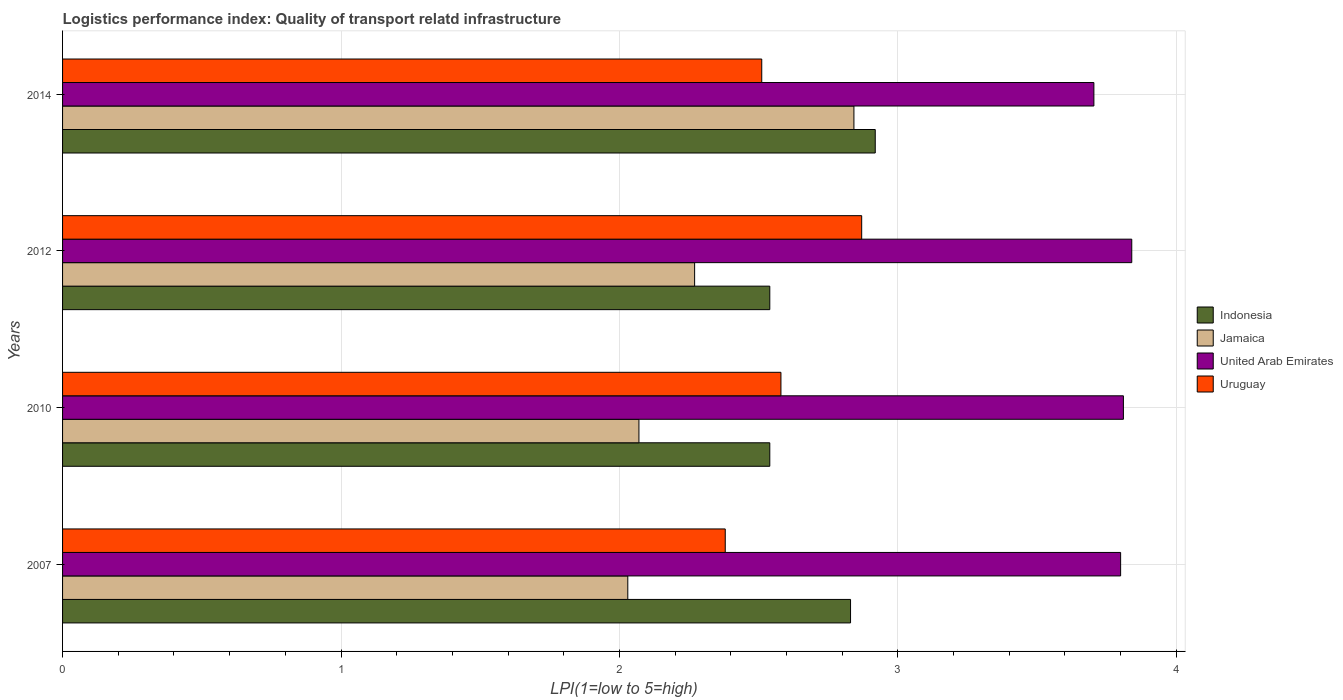How many different coloured bars are there?
Ensure brevity in your answer.  4. Are the number of bars per tick equal to the number of legend labels?
Your answer should be compact. Yes. Are the number of bars on each tick of the Y-axis equal?
Give a very brief answer. Yes. In how many cases, is the number of bars for a given year not equal to the number of legend labels?
Your answer should be very brief. 0. What is the logistics performance index in United Arab Emirates in 2010?
Offer a very short reply. 3.81. Across all years, what is the maximum logistics performance index in United Arab Emirates?
Your answer should be compact. 3.84. Across all years, what is the minimum logistics performance index in Jamaica?
Keep it short and to the point. 2.03. In which year was the logistics performance index in Uruguay maximum?
Your answer should be very brief. 2012. What is the total logistics performance index in Uruguay in the graph?
Give a very brief answer. 10.34. What is the difference between the logistics performance index in United Arab Emirates in 2010 and that in 2014?
Your answer should be very brief. 0.11. What is the difference between the logistics performance index in Indonesia in 2014 and the logistics performance index in Uruguay in 2012?
Give a very brief answer. 0.05. What is the average logistics performance index in Jamaica per year?
Keep it short and to the point. 2.3. In the year 2007, what is the difference between the logistics performance index in Uruguay and logistics performance index in Jamaica?
Offer a terse response. 0.35. What is the ratio of the logistics performance index in Jamaica in 2007 to that in 2010?
Your answer should be compact. 0.98. Is the logistics performance index in Indonesia in 2012 less than that in 2014?
Make the answer very short. Yes. Is the difference between the logistics performance index in Uruguay in 2007 and 2012 greater than the difference between the logistics performance index in Jamaica in 2007 and 2012?
Your answer should be compact. No. What is the difference between the highest and the second highest logistics performance index in Jamaica?
Make the answer very short. 0.57. What is the difference between the highest and the lowest logistics performance index in United Arab Emirates?
Ensure brevity in your answer.  0.14. In how many years, is the logistics performance index in Indonesia greater than the average logistics performance index in Indonesia taken over all years?
Ensure brevity in your answer.  2. Is the sum of the logistics performance index in Uruguay in 2007 and 2014 greater than the maximum logistics performance index in Indonesia across all years?
Offer a terse response. Yes. Is it the case that in every year, the sum of the logistics performance index in Indonesia and logistics performance index in United Arab Emirates is greater than the sum of logistics performance index in Uruguay and logistics performance index in Jamaica?
Provide a short and direct response. Yes. What does the 1st bar from the top in 2010 represents?
Give a very brief answer. Uruguay. What does the 3rd bar from the bottom in 2014 represents?
Ensure brevity in your answer.  United Arab Emirates. How many years are there in the graph?
Offer a very short reply. 4. Are the values on the major ticks of X-axis written in scientific E-notation?
Your answer should be very brief. No. Does the graph contain any zero values?
Your response must be concise. No. Does the graph contain grids?
Offer a terse response. Yes. What is the title of the graph?
Your answer should be very brief. Logistics performance index: Quality of transport relatd infrastructure. Does "Algeria" appear as one of the legend labels in the graph?
Your answer should be compact. No. What is the label or title of the X-axis?
Your answer should be compact. LPI(1=low to 5=high). What is the label or title of the Y-axis?
Your answer should be compact. Years. What is the LPI(1=low to 5=high) in Indonesia in 2007?
Keep it short and to the point. 2.83. What is the LPI(1=low to 5=high) in Jamaica in 2007?
Ensure brevity in your answer.  2.03. What is the LPI(1=low to 5=high) in Uruguay in 2007?
Make the answer very short. 2.38. What is the LPI(1=low to 5=high) of Indonesia in 2010?
Your response must be concise. 2.54. What is the LPI(1=low to 5=high) of Jamaica in 2010?
Offer a very short reply. 2.07. What is the LPI(1=low to 5=high) in United Arab Emirates in 2010?
Offer a very short reply. 3.81. What is the LPI(1=low to 5=high) of Uruguay in 2010?
Keep it short and to the point. 2.58. What is the LPI(1=low to 5=high) in Indonesia in 2012?
Offer a very short reply. 2.54. What is the LPI(1=low to 5=high) of Jamaica in 2012?
Your response must be concise. 2.27. What is the LPI(1=low to 5=high) of United Arab Emirates in 2012?
Keep it short and to the point. 3.84. What is the LPI(1=low to 5=high) of Uruguay in 2012?
Offer a terse response. 2.87. What is the LPI(1=low to 5=high) of Indonesia in 2014?
Make the answer very short. 2.92. What is the LPI(1=low to 5=high) in Jamaica in 2014?
Provide a succinct answer. 2.84. What is the LPI(1=low to 5=high) of United Arab Emirates in 2014?
Your answer should be very brief. 3.7. What is the LPI(1=low to 5=high) in Uruguay in 2014?
Make the answer very short. 2.51. Across all years, what is the maximum LPI(1=low to 5=high) in Indonesia?
Your answer should be compact. 2.92. Across all years, what is the maximum LPI(1=low to 5=high) in Jamaica?
Your answer should be compact. 2.84. Across all years, what is the maximum LPI(1=low to 5=high) of United Arab Emirates?
Your response must be concise. 3.84. Across all years, what is the maximum LPI(1=low to 5=high) in Uruguay?
Offer a very short reply. 2.87. Across all years, what is the minimum LPI(1=low to 5=high) in Indonesia?
Provide a succinct answer. 2.54. Across all years, what is the minimum LPI(1=low to 5=high) of Jamaica?
Make the answer very short. 2.03. Across all years, what is the minimum LPI(1=low to 5=high) in United Arab Emirates?
Ensure brevity in your answer.  3.7. Across all years, what is the minimum LPI(1=low to 5=high) of Uruguay?
Your response must be concise. 2.38. What is the total LPI(1=low to 5=high) in Indonesia in the graph?
Offer a terse response. 10.83. What is the total LPI(1=low to 5=high) of Jamaica in the graph?
Ensure brevity in your answer.  9.21. What is the total LPI(1=low to 5=high) of United Arab Emirates in the graph?
Make the answer very short. 15.15. What is the total LPI(1=low to 5=high) in Uruguay in the graph?
Offer a terse response. 10.34. What is the difference between the LPI(1=low to 5=high) of Indonesia in 2007 and that in 2010?
Offer a terse response. 0.29. What is the difference between the LPI(1=low to 5=high) in Jamaica in 2007 and that in 2010?
Your answer should be compact. -0.04. What is the difference between the LPI(1=low to 5=high) in United Arab Emirates in 2007 and that in 2010?
Offer a very short reply. -0.01. What is the difference between the LPI(1=low to 5=high) of Uruguay in 2007 and that in 2010?
Make the answer very short. -0.2. What is the difference between the LPI(1=low to 5=high) in Indonesia in 2007 and that in 2012?
Your answer should be compact. 0.29. What is the difference between the LPI(1=low to 5=high) in Jamaica in 2007 and that in 2012?
Keep it short and to the point. -0.24. What is the difference between the LPI(1=low to 5=high) of United Arab Emirates in 2007 and that in 2012?
Your answer should be very brief. -0.04. What is the difference between the LPI(1=low to 5=high) of Uruguay in 2007 and that in 2012?
Your response must be concise. -0.49. What is the difference between the LPI(1=low to 5=high) of Indonesia in 2007 and that in 2014?
Offer a very short reply. -0.09. What is the difference between the LPI(1=low to 5=high) in Jamaica in 2007 and that in 2014?
Provide a succinct answer. -0.81. What is the difference between the LPI(1=low to 5=high) in United Arab Emirates in 2007 and that in 2014?
Your response must be concise. 0.1. What is the difference between the LPI(1=low to 5=high) of Uruguay in 2007 and that in 2014?
Make the answer very short. -0.13. What is the difference between the LPI(1=low to 5=high) of Jamaica in 2010 and that in 2012?
Provide a succinct answer. -0.2. What is the difference between the LPI(1=low to 5=high) in United Arab Emirates in 2010 and that in 2012?
Offer a very short reply. -0.03. What is the difference between the LPI(1=low to 5=high) of Uruguay in 2010 and that in 2012?
Your response must be concise. -0.29. What is the difference between the LPI(1=low to 5=high) of Indonesia in 2010 and that in 2014?
Provide a short and direct response. -0.38. What is the difference between the LPI(1=low to 5=high) of Jamaica in 2010 and that in 2014?
Offer a terse response. -0.77. What is the difference between the LPI(1=low to 5=high) of United Arab Emirates in 2010 and that in 2014?
Your response must be concise. 0.11. What is the difference between the LPI(1=low to 5=high) of Uruguay in 2010 and that in 2014?
Your answer should be very brief. 0.07. What is the difference between the LPI(1=low to 5=high) of Indonesia in 2012 and that in 2014?
Ensure brevity in your answer.  -0.38. What is the difference between the LPI(1=low to 5=high) of Jamaica in 2012 and that in 2014?
Provide a succinct answer. -0.57. What is the difference between the LPI(1=low to 5=high) in United Arab Emirates in 2012 and that in 2014?
Your answer should be compact. 0.14. What is the difference between the LPI(1=low to 5=high) in Uruguay in 2012 and that in 2014?
Ensure brevity in your answer.  0.36. What is the difference between the LPI(1=low to 5=high) of Indonesia in 2007 and the LPI(1=low to 5=high) of Jamaica in 2010?
Offer a terse response. 0.76. What is the difference between the LPI(1=low to 5=high) in Indonesia in 2007 and the LPI(1=low to 5=high) in United Arab Emirates in 2010?
Ensure brevity in your answer.  -0.98. What is the difference between the LPI(1=low to 5=high) of Jamaica in 2007 and the LPI(1=low to 5=high) of United Arab Emirates in 2010?
Give a very brief answer. -1.78. What is the difference between the LPI(1=low to 5=high) of Jamaica in 2007 and the LPI(1=low to 5=high) of Uruguay in 2010?
Provide a succinct answer. -0.55. What is the difference between the LPI(1=low to 5=high) in United Arab Emirates in 2007 and the LPI(1=low to 5=high) in Uruguay in 2010?
Your response must be concise. 1.22. What is the difference between the LPI(1=low to 5=high) of Indonesia in 2007 and the LPI(1=low to 5=high) of Jamaica in 2012?
Your response must be concise. 0.56. What is the difference between the LPI(1=low to 5=high) of Indonesia in 2007 and the LPI(1=low to 5=high) of United Arab Emirates in 2012?
Make the answer very short. -1.01. What is the difference between the LPI(1=low to 5=high) of Indonesia in 2007 and the LPI(1=low to 5=high) of Uruguay in 2012?
Provide a succinct answer. -0.04. What is the difference between the LPI(1=low to 5=high) of Jamaica in 2007 and the LPI(1=low to 5=high) of United Arab Emirates in 2012?
Provide a succinct answer. -1.81. What is the difference between the LPI(1=low to 5=high) of Jamaica in 2007 and the LPI(1=low to 5=high) of Uruguay in 2012?
Provide a succinct answer. -0.84. What is the difference between the LPI(1=low to 5=high) in Indonesia in 2007 and the LPI(1=low to 5=high) in Jamaica in 2014?
Give a very brief answer. -0.01. What is the difference between the LPI(1=low to 5=high) in Indonesia in 2007 and the LPI(1=low to 5=high) in United Arab Emirates in 2014?
Your response must be concise. -0.87. What is the difference between the LPI(1=low to 5=high) in Indonesia in 2007 and the LPI(1=low to 5=high) in Uruguay in 2014?
Offer a very short reply. 0.32. What is the difference between the LPI(1=low to 5=high) of Jamaica in 2007 and the LPI(1=low to 5=high) of United Arab Emirates in 2014?
Offer a very short reply. -1.67. What is the difference between the LPI(1=low to 5=high) in Jamaica in 2007 and the LPI(1=low to 5=high) in Uruguay in 2014?
Your answer should be compact. -0.48. What is the difference between the LPI(1=low to 5=high) in United Arab Emirates in 2007 and the LPI(1=low to 5=high) in Uruguay in 2014?
Ensure brevity in your answer.  1.29. What is the difference between the LPI(1=low to 5=high) in Indonesia in 2010 and the LPI(1=low to 5=high) in Jamaica in 2012?
Make the answer very short. 0.27. What is the difference between the LPI(1=low to 5=high) in Indonesia in 2010 and the LPI(1=low to 5=high) in Uruguay in 2012?
Keep it short and to the point. -0.33. What is the difference between the LPI(1=low to 5=high) in Jamaica in 2010 and the LPI(1=low to 5=high) in United Arab Emirates in 2012?
Ensure brevity in your answer.  -1.77. What is the difference between the LPI(1=low to 5=high) of Jamaica in 2010 and the LPI(1=low to 5=high) of Uruguay in 2012?
Offer a terse response. -0.8. What is the difference between the LPI(1=low to 5=high) of United Arab Emirates in 2010 and the LPI(1=low to 5=high) of Uruguay in 2012?
Provide a succinct answer. 0.94. What is the difference between the LPI(1=low to 5=high) in Indonesia in 2010 and the LPI(1=low to 5=high) in Jamaica in 2014?
Your response must be concise. -0.3. What is the difference between the LPI(1=low to 5=high) in Indonesia in 2010 and the LPI(1=low to 5=high) in United Arab Emirates in 2014?
Make the answer very short. -1.16. What is the difference between the LPI(1=low to 5=high) in Indonesia in 2010 and the LPI(1=low to 5=high) in Uruguay in 2014?
Give a very brief answer. 0.03. What is the difference between the LPI(1=low to 5=high) of Jamaica in 2010 and the LPI(1=low to 5=high) of United Arab Emirates in 2014?
Provide a short and direct response. -1.63. What is the difference between the LPI(1=low to 5=high) of Jamaica in 2010 and the LPI(1=low to 5=high) of Uruguay in 2014?
Make the answer very short. -0.44. What is the difference between the LPI(1=low to 5=high) in United Arab Emirates in 2010 and the LPI(1=low to 5=high) in Uruguay in 2014?
Offer a terse response. 1.3. What is the difference between the LPI(1=low to 5=high) of Indonesia in 2012 and the LPI(1=low to 5=high) of Jamaica in 2014?
Provide a short and direct response. -0.3. What is the difference between the LPI(1=low to 5=high) in Indonesia in 2012 and the LPI(1=low to 5=high) in United Arab Emirates in 2014?
Keep it short and to the point. -1.16. What is the difference between the LPI(1=low to 5=high) of Indonesia in 2012 and the LPI(1=low to 5=high) of Uruguay in 2014?
Your response must be concise. 0.03. What is the difference between the LPI(1=low to 5=high) in Jamaica in 2012 and the LPI(1=low to 5=high) in United Arab Emirates in 2014?
Make the answer very short. -1.43. What is the difference between the LPI(1=low to 5=high) of Jamaica in 2012 and the LPI(1=low to 5=high) of Uruguay in 2014?
Provide a succinct answer. -0.24. What is the difference between the LPI(1=low to 5=high) in United Arab Emirates in 2012 and the LPI(1=low to 5=high) in Uruguay in 2014?
Keep it short and to the point. 1.33. What is the average LPI(1=low to 5=high) in Indonesia per year?
Your answer should be very brief. 2.71. What is the average LPI(1=low to 5=high) of Jamaica per year?
Your answer should be very brief. 2.3. What is the average LPI(1=low to 5=high) of United Arab Emirates per year?
Offer a very short reply. 3.79. What is the average LPI(1=low to 5=high) in Uruguay per year?
Give a very brief answer. 2.59. In the year 2007, what is the difference between the LPI(1=low to 5=high) in Indonesia and LPI(1=low to 5=high) in United Arab Emirates?
Ensure brevity in your answer.  -0.97. In the year 2007, what is the difference between the LPI(1=low to 5=high) in Indonesia and LPI(1=low to 5=high) in Uruguay?
Offer a terse response. 0.45. In the year 2007, what is the difference between the LPI(1=low to 5=high) in Jamaica and LPI(1=low to 5=high) in United Arab Emirates?
Provide a short and direct response. -1.77. In the year 2007, what is the difference between the LPI(1=low to 5=high) of Jamaica and LPI(1=low to 5=high) of Uruguay?
Your answer should be very brief. -0.35. In the year 2007, what is the difference between the LPI(1=low to 5=high) of United Arab Emirates and LPI(1=low to 5=high) of Uruguay?
Ensure brevity in your answer.  1.42. In the year 2010, what is the difference between the LPI(1=low to 5=high) of Indonesia and LPI(1=low to 5=high) of Jamaica?
Give a very brief answer. 0.47. In the year 2010, what is the difference between the LPI(1=low to 5=high) in Indonesia and LPI(1=low to 5=high) in United Arab Emirates?
Make the answer very short. -1.27. In the year 2010, what is the difference between the LPI(1=low to 5=high) in Indonesia and LPI(1=low to 5=high) in Uruguay?
Provide a short and direct response. -0.04. In the year 2010, what is the difference between the LPI(1=low to 5=high) in Jamaica and LPI(1=low to 5=high) in United Arab Emirates?
Offer a terse response. -1.74. In the year 2010, what is the difference between the LPI(1=low to 5=high) of Jamaica and LPI(1=low to 5=high) of Uruguay?
Offer a terse response. -0.51. In the year 2010, what is the difference between the LPI(1=low to 5=high) of United Arab Emirates and LPI(1=low to 5=high) of Uruguay?
Your answer should be very brief. 1.23. In the year 2012, what is the difference between the LPI(1=low to 5=high) of Indonesia and LPI(1=low to 5=high) of Jamaica?
Give a very brief answer. 0.27. In the year 2012, what is the difference between the LPI(1=low to 5=high) in Indonesia and LPI(1=low to 5=high) in Uruguay?
Provide a short and direct response. -0.33. In the year 2012, what is the difference between the LPI(1=low to 5=high) of Jamaica and LPI(1=low to 5=high) of United Arab Emirates?
Your answer should be compact. -1.57. In the year 2012, what is the difference between the LPI(1=low to 5=high) of Jamaica and LPI(1=low to 5=high) of Uruguay?
Your answer should be compact. -0.6. In the year 2014, what is the difference between the LPI(1=low to 5=high) of Indonesia and LPI(1=low to 5=high) of Jamaica?
Offer a terse response. 0.08. In the year 2014, what is the difference between the LPI(1=low to 5=high) of Indonesia and LPI(1=low to 5=high) of United Arab Emirates?
Give a very brief answer. -0.79. In the year 2014, what is the difference between the LPI(1=low to 5=high) in Indonesia and LPI(1=low to 5=high) in Uruguay?
Ensure brevity in your answer.  0.41. In the year 2014, what is the difference between the LPI(1=low to 5=high) of Jamaica and LPI(1=low to 5=high) of United Arab Emirates?
Your answer should be compact. -0.86. In the year 2014, what is the difference between the LPI(1=low to 5=high) of Jamaica and LPI(1=low to 5=high) of Uruguay?
Your answer should be compact. 0.33. In the year 2014, what is the difference between the LPI(1=low to 5=high) in United Arab Emirates and LPI(1=low to 5=high) in Uruguay?
Offer a terse response. 1.19. What is the ratio of the LPI(1=low to 5=high) in Indonesia in 2007 to that in 2010?
Keep it short and to the point. 1.11. What is the ratio of the LPI(1=low to 5=high) in Jamaica in 2007 to that in 2010?
Your answer should be compact. 0.98. What is the ratio of the LPI(1=low to 5=high) in United Arab Emirates in 2007 to that in 2010?
Your answer should be very brief. 1. What is the ratio of the LPI(1=low to 5=high) in Uruguay in 2007 to that in 2010?
Offer a very short reply. 0.92. What is the ratio of the LPI(1=low to 5=high) in Indonesia in 2007 to that in 2012?
Your answer should be compact. 1.11. What is the ratio of the LPI(1=low to 5=high) in Jamaica in 2007 to that in 2012?
Make the answer very short. 0.89. What is the ratio of the LPI(1=low to 5=high) in Uruguay in 2007 to that in 2012?
Make the answer very short. 0.83. What is the ratio of the LPI(1=low to 5=high) in Indonesia in 2007 to that in 2014?
Provide a succinct answer. 0.97. What is the ratio of the LPI(1=low to 5=high) of Jamaica in 2007 to that in 2014?
Offer a terse response. 0.71. What is the ratio of the LPI(1=low to 5=high) in United Arab Emirates in 2007 to that in 2014?
Keep it short and to the point. 1.03. What is the ratio of the LPI(1=low to 5=high) of Uruguay in 2007 to that in 2014?
Ensure brevity in your answer.  0.95. What is the ratio of the LPI(1=low to 5=high) in Indonesia in 2010 to that in 2012?
Provide a short and direct response. 1. What is the ratio of the LPI(1=low to 5=high) of Jamaica in 2010 to that in 2012?
Provide a succinct answer. 0.91. What is the ratio of the LPI(1=low to 5=high) in United Arab Emirates in 2010 to that in 2012?
Ensure brevity in your answer.  0.99. What is the ratio of the LPI(1=low to 5=high) of Uruguay in 2010 to that in 2012?
Your answer should be very brief. 0.9. What is the ratio of the LPI(1=low to 5=high) in Indonesia in 2010 to that in 2014?
Make the answer very short. 0.87. What is the ratio of the LPI(1=low to 5=high) of Jamaica in 2010 to that in 2014?
Offer a terse response. 0.73. What is the ratio of the LPI(1=low to 5=high) in United Arab Emirates in 2010 to that in 2014?
Make the answer very short. 1.03. What is the ratio of the LPI(1=low to 5=high) of Uruguay in 2010 to that in 2014?
Keep it short and to the point. 1.03. What is the ratio of the LPI(1=low to 5=high) of Indonesia in 2012 to that in 2014?
Provide a succinct answer. 0.87. What is the ratio of the LPI(1=low to 5=high) of Jamaica in 2012 to that in 2014?
Your answer should be very brief. 0.8. What is the ratio of the LPI(1=low to 5=high) in United Arab Emirates in 2012 to that in 2014?
Ensure brevity in your answer.  1.04. What is the ratio of the LPI(1=low to 5=high) in Uruguay in 2012 to that in 2014?
Provide a succinct answer. 1.14. What is the difference between the highest and the second highest LPI(1=low to 5=high) of Indonesia?
Your answer should be very brief. 0.09. What is the difference between the highest and the second highest LPI(1=low to 5=high) of Jamaica?
Provide a succinct answer. 0.57. What is the difference between the highest and the second highest LPI(1=low to 5=high) in Uruguay?
Keep it short and to the point. 0.29. What is the difference between the highest and the lowest LPI(1=low to 5=high) in Indonesia?
Give a very brief answer. 0.38. What is the difference between the highest and the lowest LPI(1=low to 5=high) of Jamaica?
Keep it short and to the point. 0.81. What is the difference between the highest and the lowest LPI(1=low to 5=high) in United Arab Emirates?
Your response must be concise. 0.14. What is the difference between the highest and the lowest LPI(1=low to 5=high) of Uruguay?
Your answer should be compact. 0.49. 